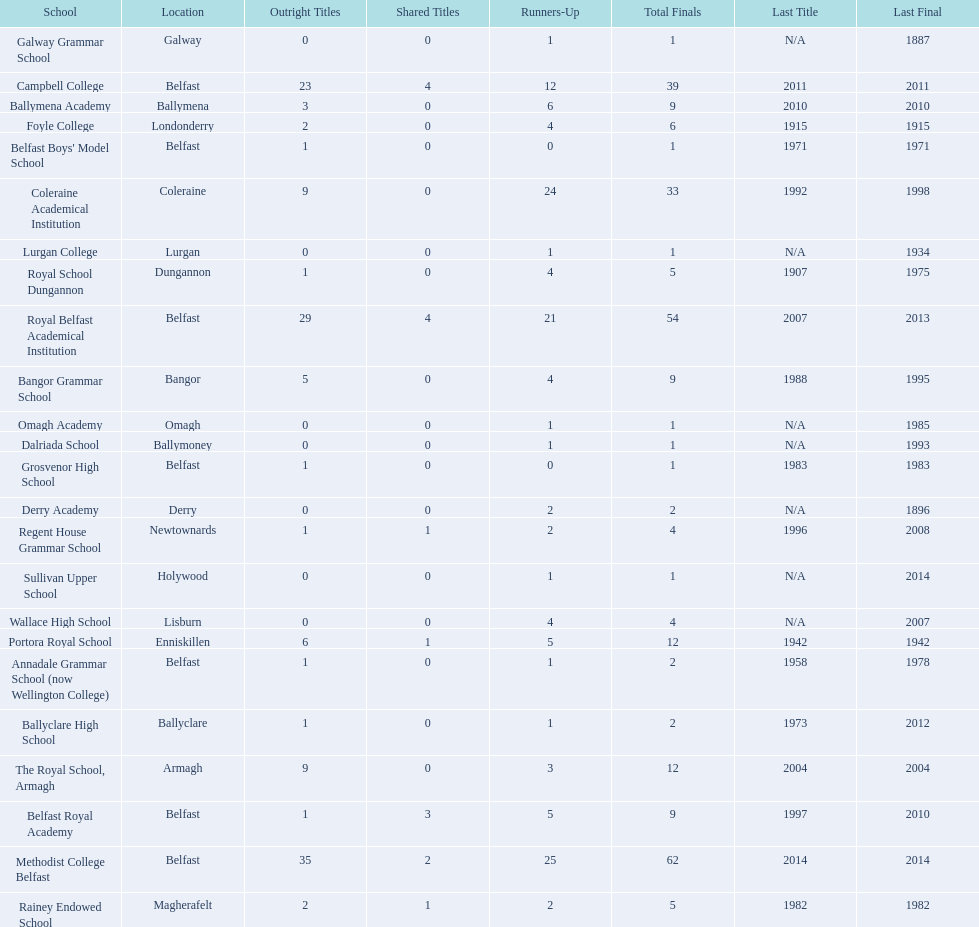What is the number of schools with at least 3 shared championships? 3. 